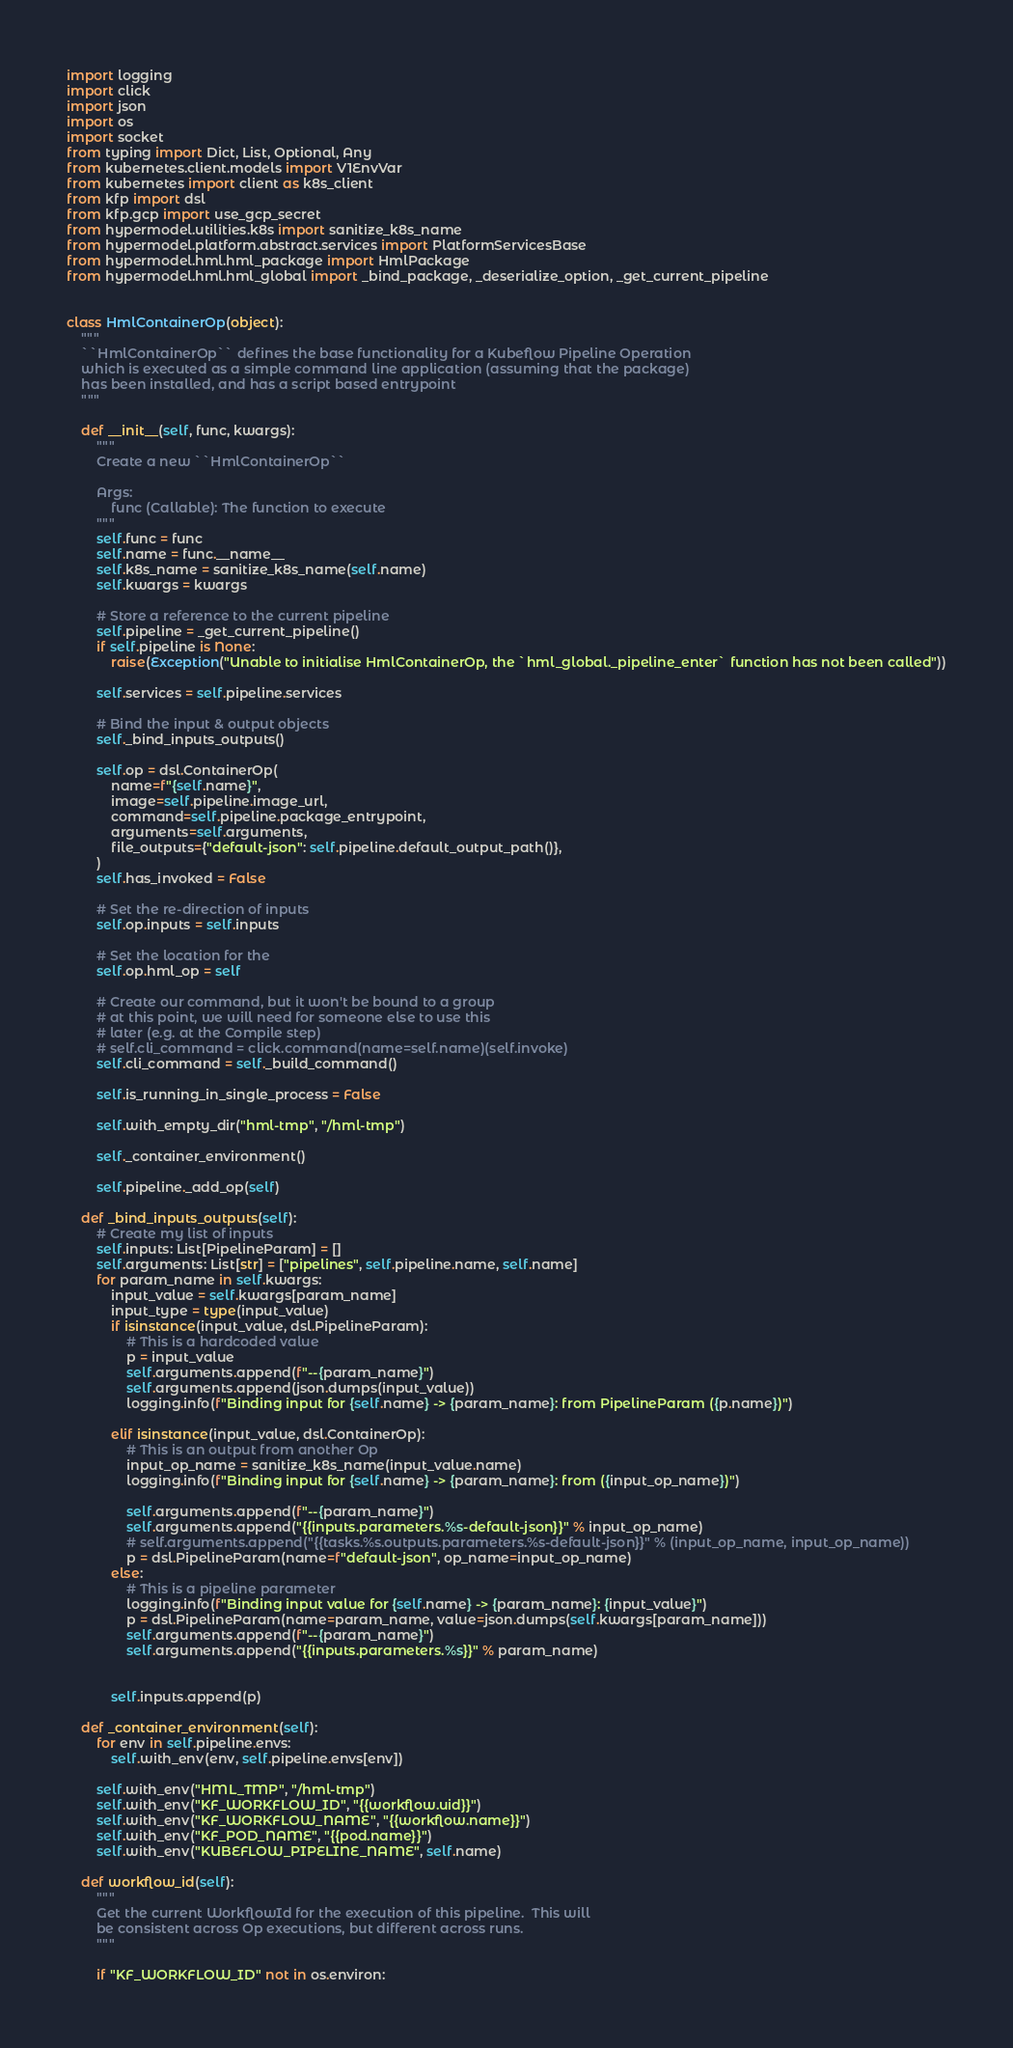<code> <loc_0><loc_0><loc_500><loc_500><_Python_>import logging
import click
import json
import os
import socket
from typing import Dict, List, Optional, Any
from kubernetes.client.models import V1EnvVar
from kubernetes import client as k8s_client
from kfp import dsl
from kfp.gcp import use_gcp_secret
from hypermodel.utilities.k8s import sanitize_k8s_name
from hypermodel.platform.abstract.services import PlatformServicesBase
from hypermodel.hml.hml_package import HmlPackage
from hypermodel.hml.hml_global import _bind_package, _deserialize_option, _get_current_pipeline


class HmlContainerOp(object):
    """
    ``HmlContainerOp`` defines the base functionality for a Kubeflow Pipeline Operation
    which is executed as a simple command line application (assuming that the package)
    has been installed, and has a script based entrypoint
    """

    def __init__(self, func, kwargs):
        """
        Create a new ``HmlContainerOp``

        Args:
            func (Callable): The function to execute
        """
        self.func = func
        self.name = func.__name__
        self.k8s_name = sanitize_k8s_name(self.name)
        self.kwargs = kwargs

        # Store a reference to the current pipeline
        self.pipeline = _get_current_pipeline()
        if self.pipeline is None:
            raise(Exception("Unable to initialise HmlContainerOp, the `hml_global._pipeline_enter` function has not been called"))

        self.services = self.pipeline.services

        # Bind the input & output objects
        self._bind_inputs_outputs()

        self.op = dsl.ContainerOp(
            name=f"{self.name}",
            image=self.pipeline.image_url,
            command=self.pipeline.package_entrypoint,
            arguments=self.arguments,
            file_outputs={"default-json": self.pipeline.default_output_path()},
        )
        self.has_invoked = False

        # Set the re-direction of inputs
        self.op.inputs = self.inputs

        # Set the location for the
        self.op.hml_op = self

        # Create our command, but it won't be bound to a group
        # at this point, we will need for someone else to use this
        # later (e.g. at the Compile step)
        # self.cli_command = click.command(name=self.name)(self.invoke)
        self.cli_command = self._build_command()

        self.is_running_in_single_process = False

        self.with_empty_dir("hml-tmp", "/hml-tmp")

        self._container_environment()

        self.pipeline._add_op(self)

    def _bind_inputs_outputs(self):
        # Create my list of inputs
        self.inputs: List[PipelineParam] = []
        self.arguments: List[str] = ["pipelines", self.pipeline.name, self.name]
        for param_name in self.kwargs:
            input_value = self.kwargs[param_name]
            input_type = type(input_value)
            if isinstance(input_value, dsl.PipelineParam):
                # This is a hardcoded value
                p = input_value
                self.arguments.append(f"--{param_name}")
                self.arguments.append(json.dumps(input_value))
                logging.info(f"Binding input for {self.name} -> {param_name}: from PipelineParam ({p.name})")

            elif isinstance(input_value, dsl.ContainerOp):
                # This is an output from another Op
                input_op_name = sanitize_k8s_name(input_value.name)
                logging.info(f"Binding input for {self.name} -> {param_name}: from ({input_op_name})")

                self.arguments.append(f"--{param_name}")
                self.arguments.append("{{inputs.parameters.%s-default-json}}" % input_op_name)
                # self.arguments.append("{{tasks.%s.outputs.parameters.%s-default-json}}" % (input_op_name, input_op_name))
                p = dsl.PipelineParam(name=f"default-json", op_name=input_op_name)
            else:
                # This is a pipeline parameter
                logging.info(f"Binding input value for {self.name} -> {param_name}: {input_value}")
                p = dsl.PipelineParam(name=param_name, value=json.dumps(self.kwargs[param_name]))
                self.arguments.append(f"--{param_name}")
                self.arguments.append("{{inputs.parameters.%s}}" % param_name)


            self.inputs.append(p)

    def _container_environment(self):
        for env in self.pipeline.envs:
            self.with_env(env, self.pipeline.envs[env])

        self.with_env("HML_TMP", "/hml-tmp")
        self.with_env("KF_WORKFLOW_ID", "{{workflow.uid}}")
        self.with_env("KF_WORKFLOW_NAME", "{{workflow.name}}")
        self.with_env("KF_POD_NAME", "{{pod.name}}")
        self.with_env("KUBEFLOW_PIPELINE_NAME", self.name)

    def workflow_id(self):
        """
        Get the current WorkflowId for the execution of this pipeline.  This will 
        be consistent across Op executions, but different across runs.
        """

        if "KF_WORKFLOW_ID" not in os.environ:</code> 